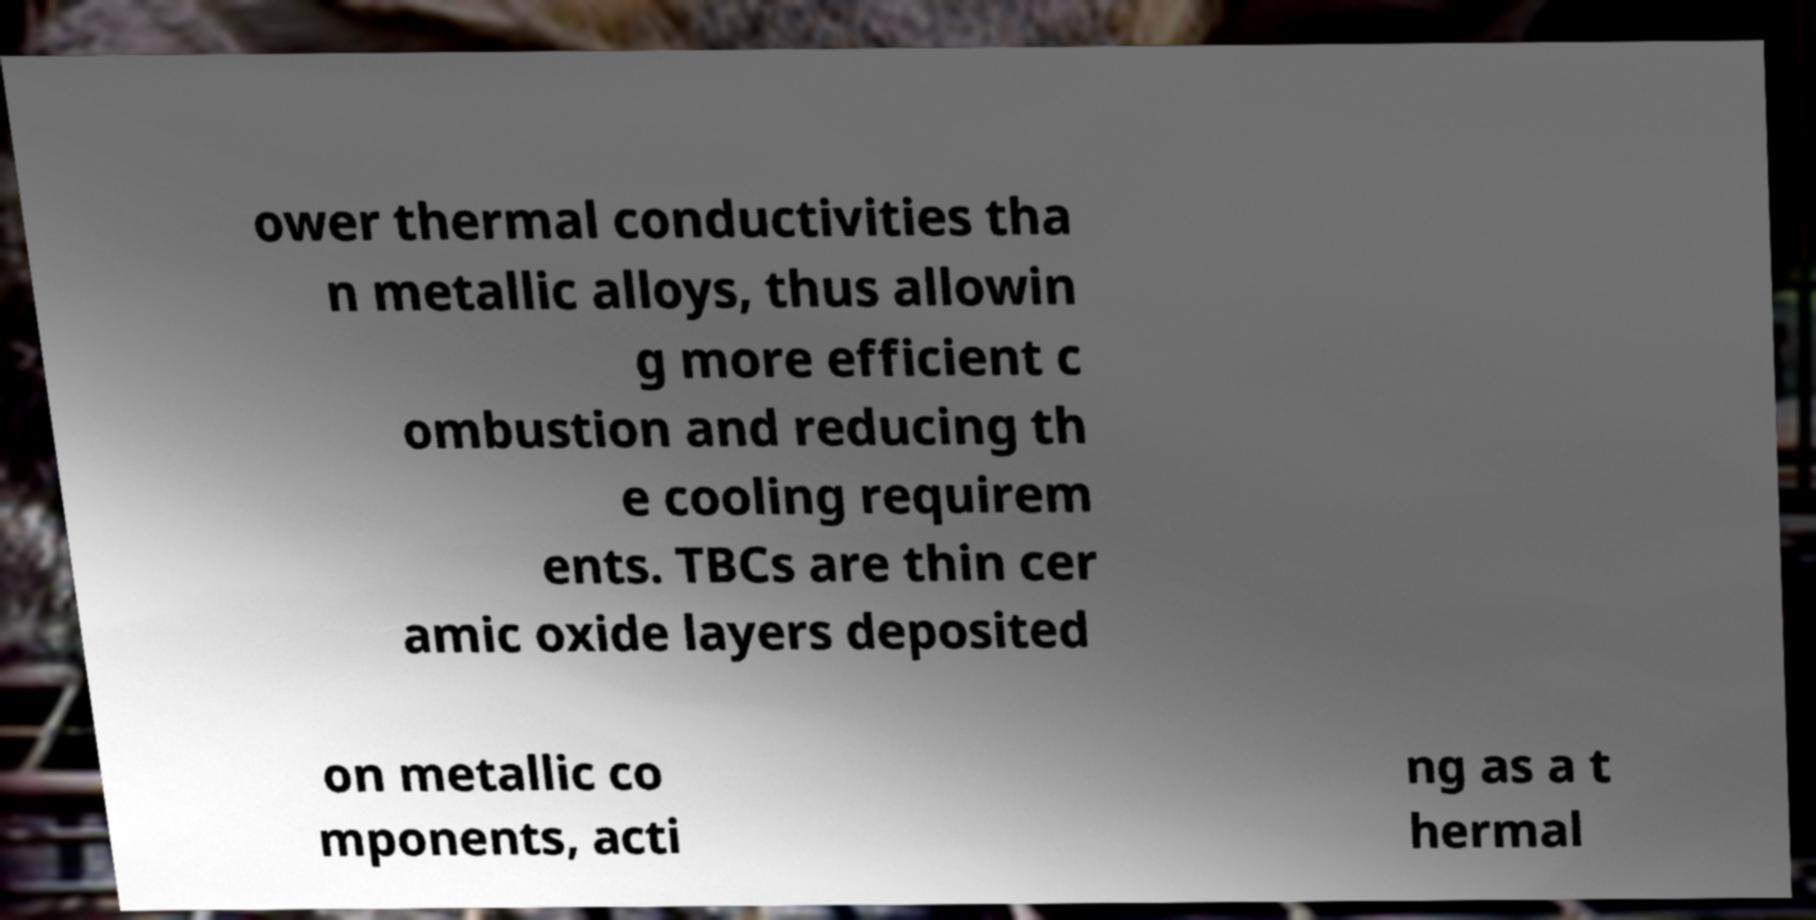Can you read and provide the text displayed in the image?This photo seems to have some interesting text. Can you extract and type it out for me? ower thermal conductivities tha n metallic alloys, thus allowin g more efficient c ombustion and reducing th e cooling requirem ents. TBCs are thin cer amic oxide layers deposited on metallic co mponents, acti ng as a t hermal 